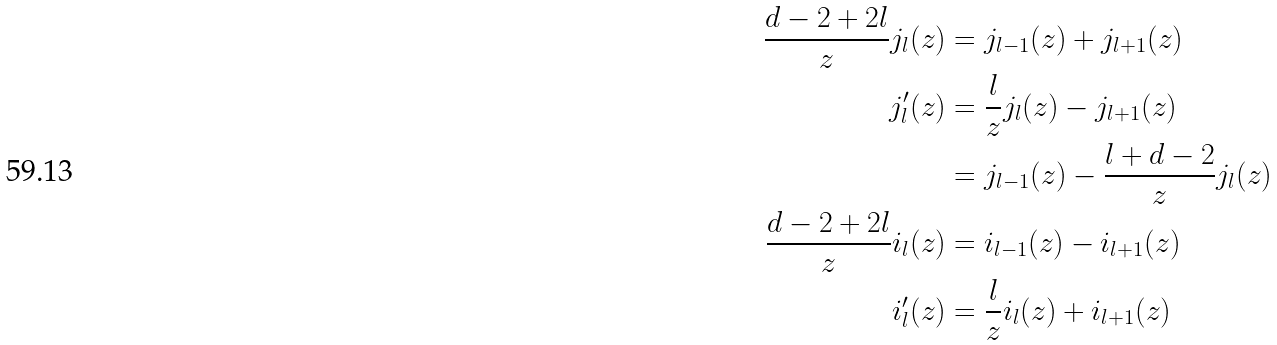<formula> <loc_0><loc_0><loc_500><loc_500>\frac { d - 2 + 2 l } { z } j _ { l } ( z ) & = j _ { l - 1 } ( z ) + j _ { l + 1 } ( z ) \\ j _ { l } ^ { \prime } ( z ) & = \frac { l } { z } j _ { l } ( z ) - j _ { l + 1 } ( z ) \\ & = j _ { l - 1 } ( z ) - \frac { l + d - 2 } { z } j _ { l } ( z ) \\ \frac { d - 2 + 2 l } { z } i _ { l } ( z ) & = i _ { l - 1 } ( z ) - i _ { l + 1 } ( z ) \\ i _ { l } ^ { \prime } ( z ) & = \frac { l } { z } i _ { l } ( z ) + i _ { l + 1 } ( z )</formula> 